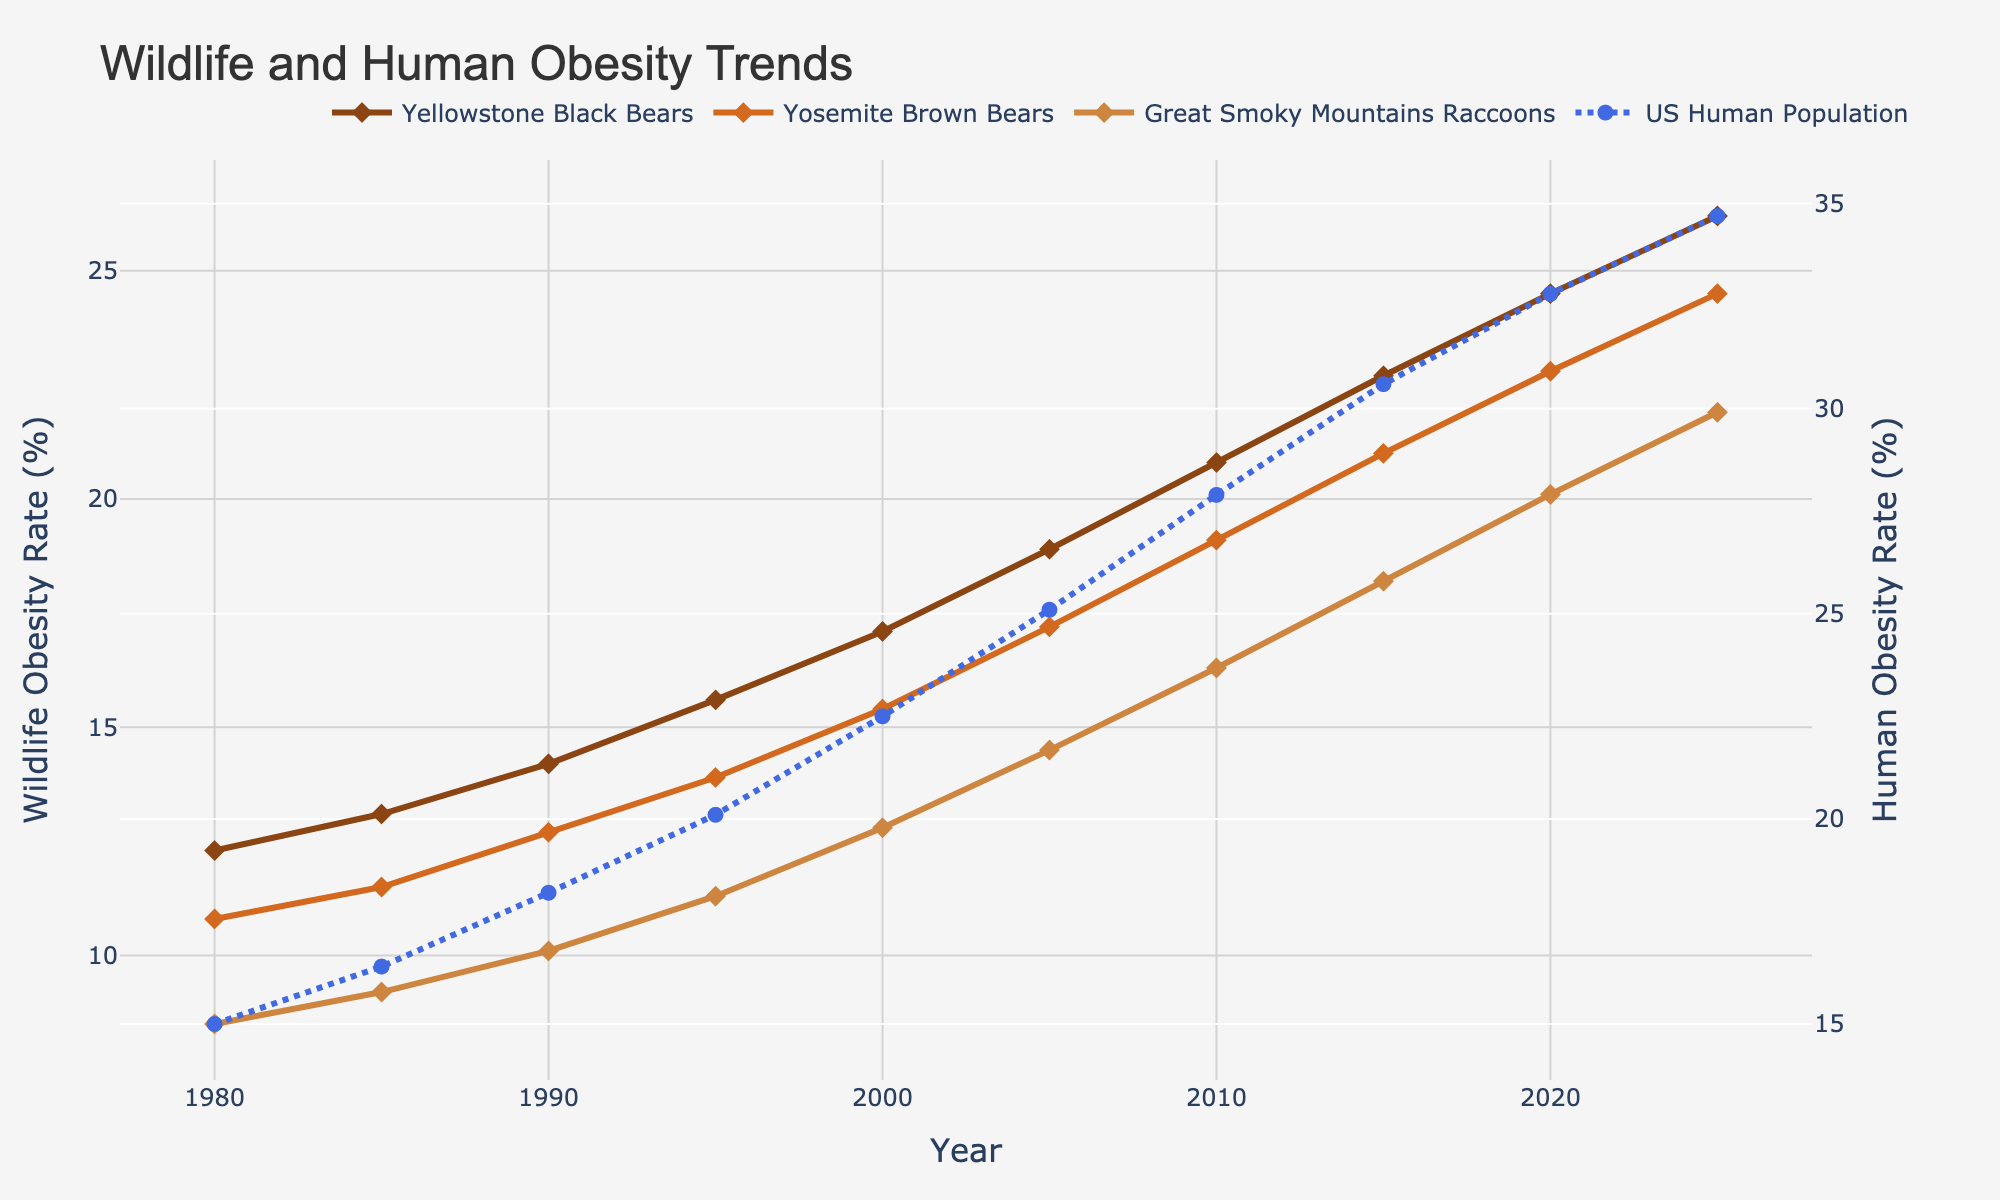What is the obesity rate of Yellowstone Black Bears in 2010? Look at the point where the brown line intersects 2010 on the x-axis, which shows 20.8%.
Answer: 20.8% Which species had the highest obesity rate in 2025? Compare the values for each species at 2025. Yellowstone Black Bears had 26.2%, Yosemite Brown Bears had 24.5%, and Great Smoky Mountains Raccoons had 21.9%.
Answer: Yellowstone Black Bears How did human obesity rates change from 1980 to 2025? Compare the human obesity rates from 1980 (15.0%) to 2025 (34.7%) by calculating the difference, 34.7% - 15.0% = 19.7%.
Answer: Increased by 19.7% What is the overall trend of the obesity rate for Great Smoky Mountains Raccoons from 1980 to 2020? Observe the orange line representing Great Smoky Mountains Raccoons; the line ascends consistently from 8.5% to 20.1%, showing an increasing trend.
Answer: Increasing trend Between 2000 and 2020, which animal showed the most significant increase in obesity rates? Calculate the differences for each species: Yellowstone Black Bears (24.5% - 17.1% = 7.4%), Yosemite Brown Bears (22.8% - 15.4% = 7.4%), Great Smoky Mountains Raccoons (20.1% - 12.8% = 7.3%). Then compare the differences.
Answer: Yellowstone Black Bears and Yosemite Brown Bears (tie) In what year did human obesity rates surpass 25%? Trace the blue dotted line and find the first year where it crosses 25%, which is 2005 (25.1%).
Answer: 2005 Is the increase in wildlife obesity rates consistent with the increase in human obesity rates? Compare the slopes for both lines across the years. Both wildlife and human lines increase steadily, indicating a consistent trend.
Answer: Yes What was the average obesity rate for Yosemite Brown Bears between 1980 and 2020? Find the values for Yosemite Brown Bears from 1980 to 2020: (10.8 + 11.5 + 12.7 + 13.9 + 15.4 + 17.2 + 19.1 + 21.0 + 22.8) / 9 = 16.0%.
Answer: 16.0% Compare the obesity rates of Great Smoky Mountains Raccoons and US Human Population in 2005. Which is higher? Look at 2005 values: Raccoons (14.5%), Humans (25.1%).
Answer: US Human Population By how many percentage points did the obesity rate of Yellowstone Black Bears increase from 1990 to 2015? Calculate 2015 (22.7%) - 1990 (14.2%) = 8.5%.
Answer: 8.5% 